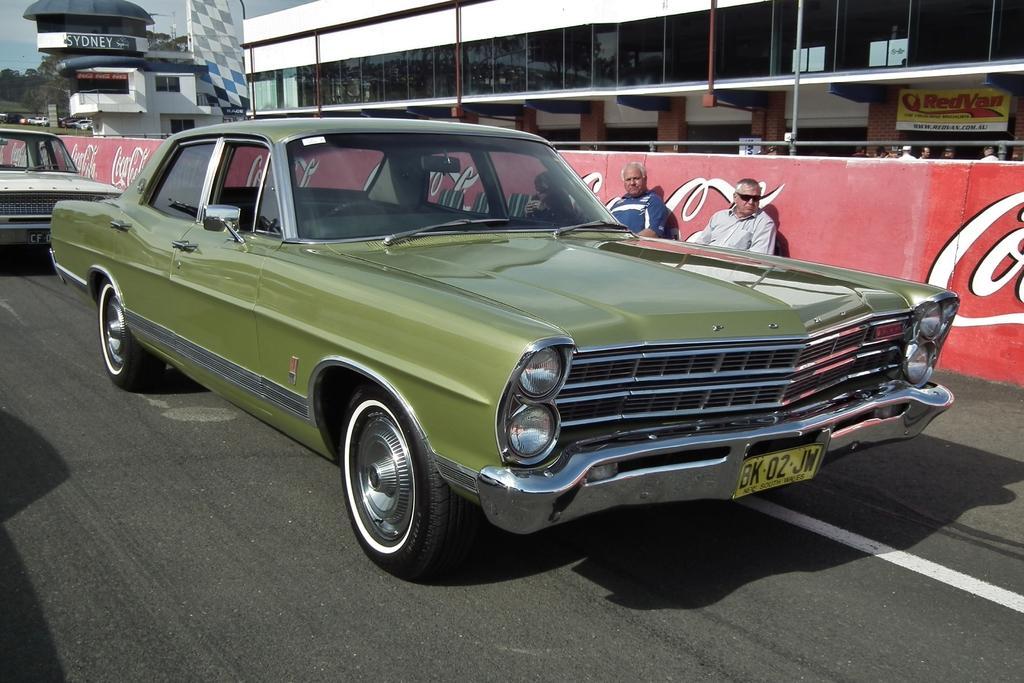Could you give a brief overview of what you see in this image? We can see cars on the road and there are two people sitting, behind these two people we can see hoarding. In the background we can see buildings, trees, boards, vehicles and sky. 